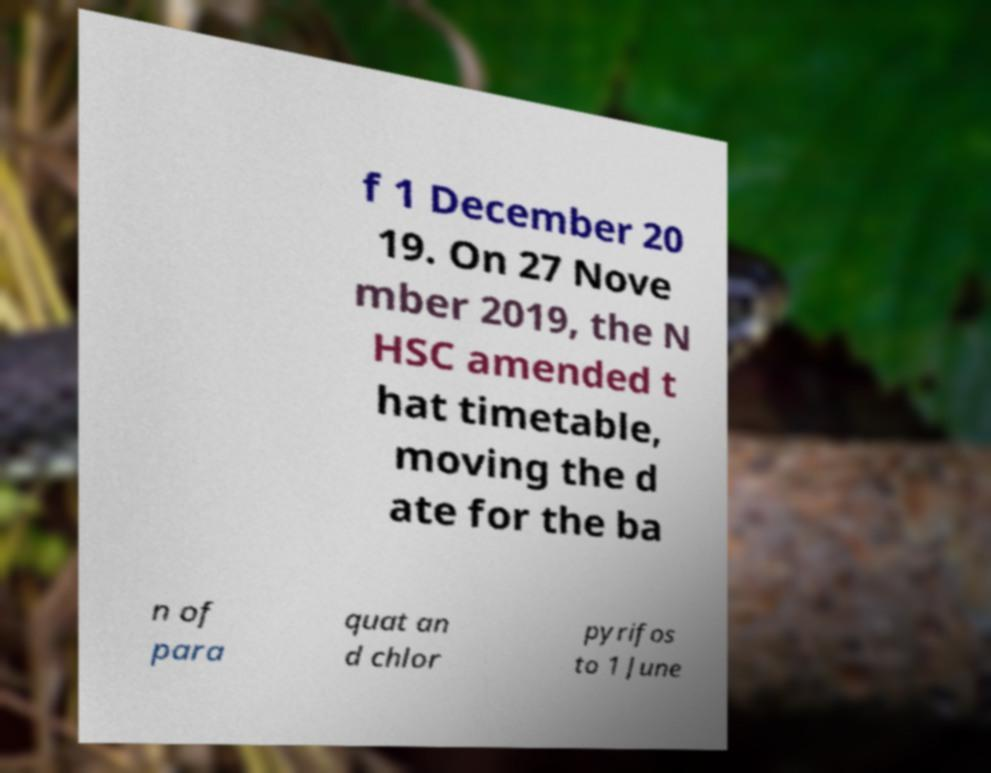What messages or text are displayed in this image? I need them in a readable, typed format. f 1 December 20 19. On 27 Nove mber 2019, the N HSC amended t hat timetable, moving the d ate for the ba n of para quat an d chlor pyrifos to 1 June 